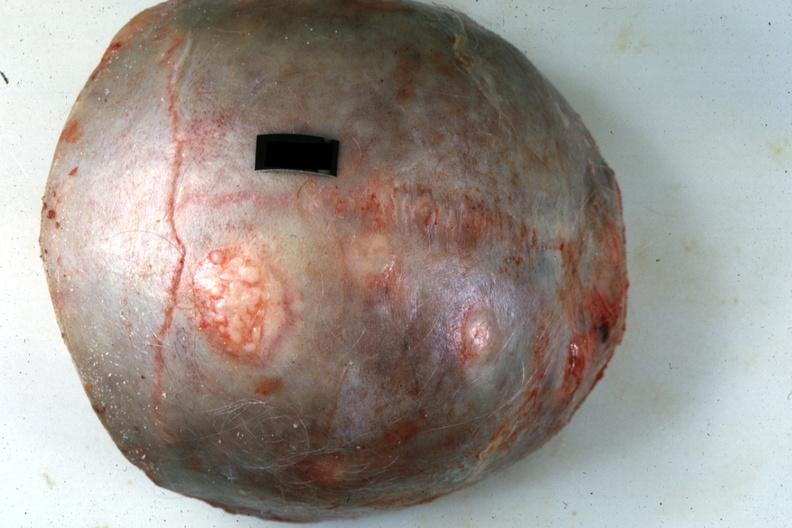s bone, calvarium present?
Answer the question using a single word or phrase. Yes 